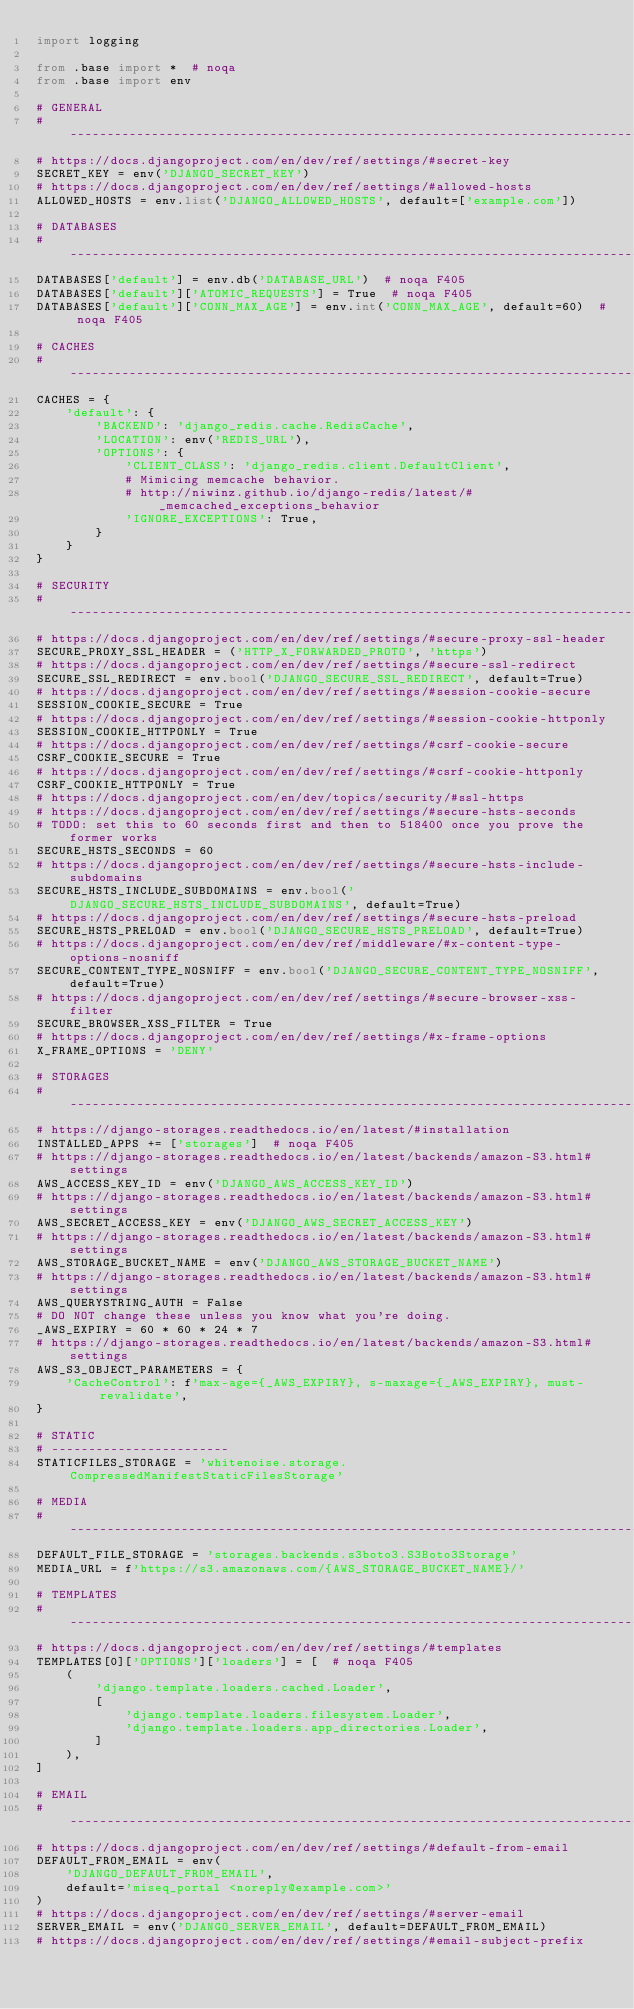<code> <loc_0><loc_0><loc_500><loc_500><_Python_>import logging

from .base import *  # noqa
from .base import env

# GENERAL
# ------------------------------------------------------------------------------
# https://docs.djangoproject.com/en/dev/ref/settings/#secret-key
SECRET_KEY = env('DJANGO_SECRET_KEY')
# https://docs.djangoproject.com/en/dev/ref/settings/#allowed-hosts
ALLOWED_HOSTS = env.list('DJANGO_ALLOWED_HOSTS', default=['example.com'])

# DATABASES
# ------------------------------------------------------------------------------
DATABASES['default'] = env.db('DATABASE_URL')  # noqa F405
DATABASES['default']['ATOMIC_REQUESTS'] = True  # noqa F405
DATABASES['default']['CONN_MAX_AGE'] = env.int('CONN_MAX_AGE', default=60)  # noqa F405

# CACHES
# ------------------------------------------------------------------------------
CACHES = {
    'default': {
        'BACKEND': 'django_redis.cache.RedisCache',
        'LOCATION': env('REDIS_URL'),
        'OPTIONS': {
            'CLIENT_CLASS': 'django_redis.client.DefaultClient',
            # Mimicing memcache behavior.
            # http://niwinz.github.io/django-redis/latest/#_memcached_exceptions_behavior
            'IGNORE_EXCEPTIONS': True,
        }
    }
}

# SECURITY
# ------------------------------------------------------------------------------
# https://docs.djangoproject.com/en/dev/ref/settings/#secure-proxy-ssl-header
SECURE_PROXY_SSL_HEADER = ('HTTP_X_FORWARDED_PROTO', 'https')
# https://docs.djangoproject.com/en/dev/ref/settings/#secure-ssl-redirect
SECURE_SSL_REDIRECT = env.bool('DJANGO_SECURE_SSL_REDIRECT', default=True)
# https://docs.djangoproject.com/en/dev/ref/settings/#session-cookie-secure
SESSION_COOKIE_SECURE = True
# https://docs.djangoproject.com/en/dev/ref/settings/#session-cookie-httponly
SESSION_COOKIE_HTTPONLY = True
# https://docs.djangoproject.com/en/dev/ref/settings/#csrf-cookie-secure
CSRF_COOKIE_SECURE = True
# https://docs.djangoproject.com/en/dev/ref/settings/#csrf-cookie-httponly
CSRF_COOKIE_HTTPONLY = True
# https://docs.djangoproject.com/en/dev/topics/security/#ssl-https
# https://docs.djangoproject.com/en/dev/ref/settings/#secure-hsts-seconds
# TODO: set this to 60 seconds first and then to 518400 once you prove the former works
SECURE_HSTS_SECONDS = 60
# https://docs.djangoproject.com/en/dev/ref/settings/#secure-hsts-include-subdomains
SECURE_HSTS_INCLUDE_SUBDOMAINS = env.bool('DJANGO_SECURE_HSTS_INCLUDE_SUBDOMAINS', default=True)
# https://docs.djangoproject.com/en/dev/ref/settings/#secure-hsts-preload
SECURE_HSTS_PRELOAD = env.bool('DJANGO_SECURE_HSTS_PRELOAD', default=True)
# https://docs.djangoproject.com/en/dev/ref/middleware/#x-content-type-options-nosniff
SECURE_CONTENT_TYPE_NOSNIFF = env.bool('DJANGO_SECURE_CONTENT_TYPE_NOSNIFF', default=True)
# https://docs.djangoproject.com/en/dev/ref/settings/#secure-browser-xss-filter
SECURE_BROWSER_XSS_FILTER = True
# https://docs.djangoproject.com/en/dev/ref/settings/#x-frame-options
X_FRAME_OPTIONS = 'DENY'

# STORAGES
# ------------------------------------------------------------------------------
# https://django-storages.readthedocs.io/en/latest/#installation
INSTALLED_APPS += ['storages']  # noqa F405
# https://django-storages.readthedocs.io/en/latest/backends/amazon-S3.html#settings
AWS_ACCESS_KEY_ID = env('DJANGO_AWS_ACCESS_KEY_ID')
# https://django-storages.readthedocs.io/en/latest/backends/amazon-S3.html#settings
AWS_SECRET_ACCESS_KEY = env('DJANGO_AWS_SECRET_ACCESS_KEY')
# https://django-storages.readthedocs.io/en/latest/backends/amazon-S3.html#settings
AWS_STORAGE_BUCKET_NAME = env('DJANGO_AWS_STORAGE_BUCKET_NAME')
# https://django-storages.readthedocs.io/en/latest/backends/amazon-S3.html#settings
AWS_QUERYSTRING_AUTH = False
# DO NOT change these unless you know what you're doing.
_AWS_EXPIRY = 60 * 60 * 24 * 7
# https://django-storages.readthedocs.io/en/latest/backends/amazon-S3.html#settings
AWS_S3_OBJECT_PARAMETERS = {
    'CacheControl': f'max-age={_AWS_EXPIRY}, s-maxage={_AWS_EXPIRY}, must-revalidate',
}

# STATIC
# ------------------------
STATICFILES_STORAGE = 'whitenoise.storage.CompressedManifestStaticFilesStorage'

# MEDIA
# ------------------------------------------------------------------------------
DEFAULT_FILE_STORAGE = 'storages.backends.s3boto3.S3Boto3Storage'
MEDIA_URL = f'https://s3.amazonaws.com/{AWS_STORAGE_BUCKET_NAME}/'

# TEMPLATES
# ------------------------------------------------------------------------------
# https://docs.djangoproject.com/en/dev/ref/settings/#templates
TEMPLATES[0]['OPTIONS']['loaders'] = [  # noqa F405
    (
        'django.template.loaders.cached.Loader',
        [
            'django.template.loaders.filesystem.Loader',
            'django.template.loaders.app_directories.Loader',
        ]
    ),
]

# EMAIL
# ------------------------------------------------------------------------------
# https://docs.djangoproject.com/en/dev/ref/settings/#default-from-email
DEFAULT_FROM_EMAIL = env(
    'DJANGO_DEFAULT_FROM_EMAIL',
    default='miseq_portal <noreply@example.com>'
)
# https://docs.djangoproject.com/en/dev/ref/settings/#server-email
SERVER_EMAIL = env('DJANGO_SERVER_EMAIL', default=DEFAULT_FROM_EMAIL)
# https://docs.djangoproject.com/en/dev/ref/settings/#email-subject-prefix</code> 